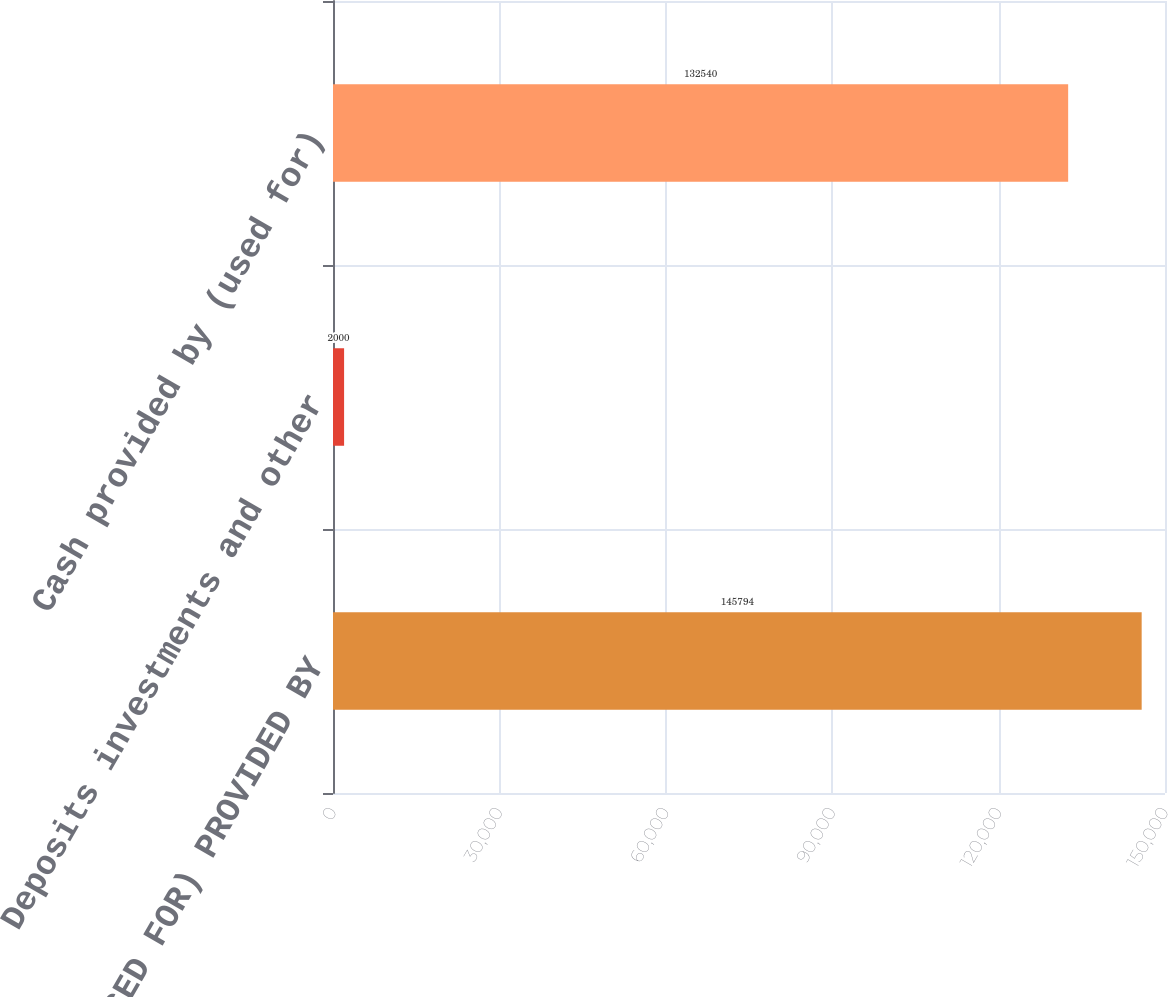Convert chart. <chart><loc_0><loc_0><loc_500><loc_500><bar_chart><fcel>CASH (USED FOR) PROVIDED BY<fcel>Deposits investments and other<fcel>Cash provided by (used for)<nl><fcel>145794<fcel>2000<fcel>132540<nl></chart> 